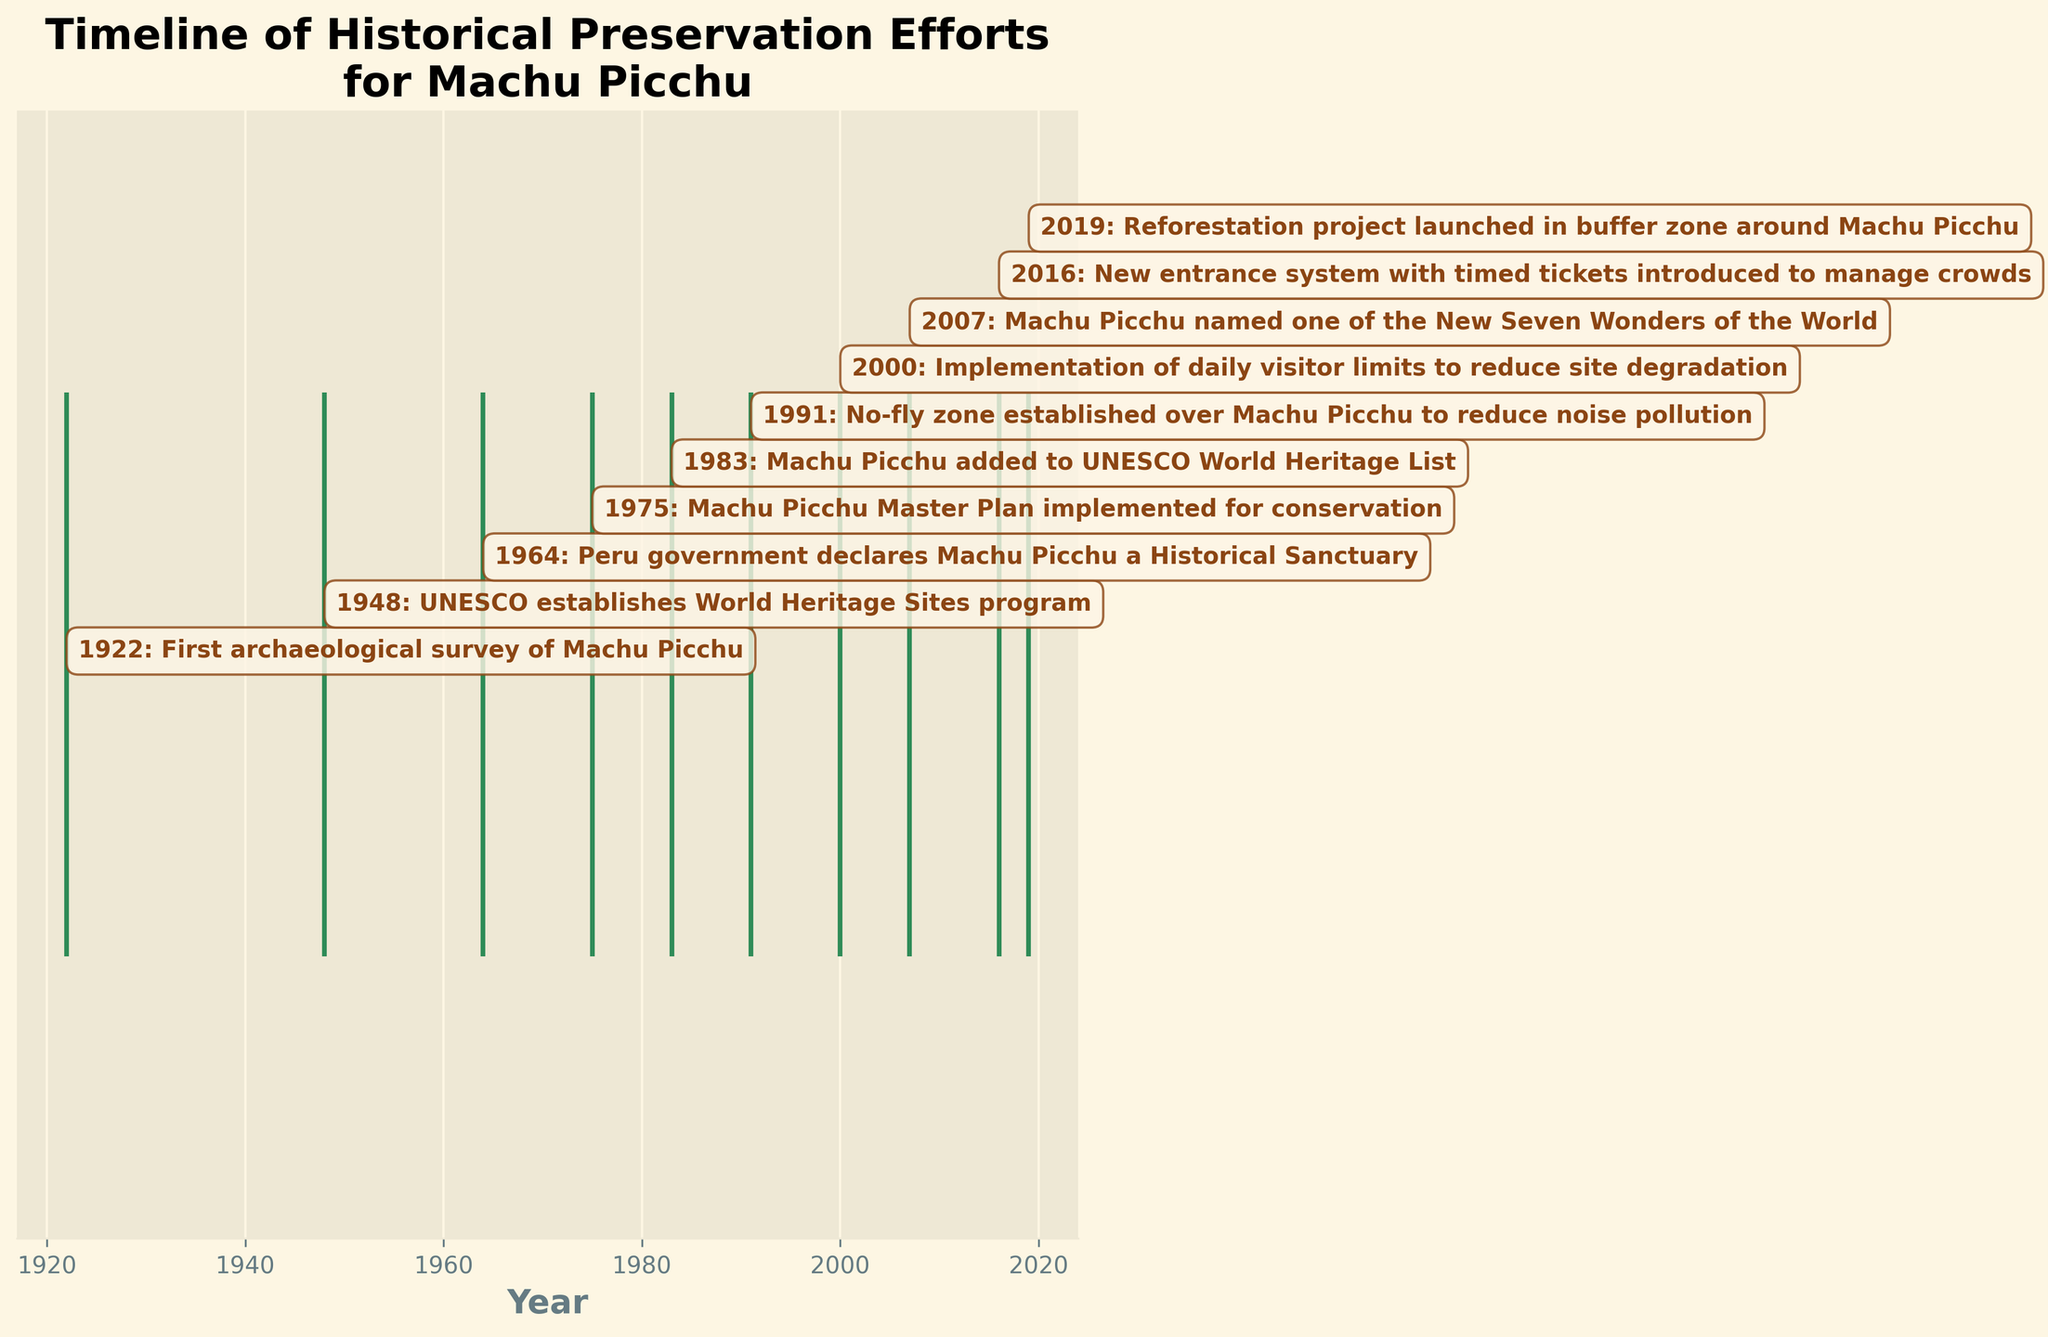what is the title of the plot? The title of the plot is displayed at the top center of the figure. It summarizes the theme of the plot.
Answer: Timeline of Historical Preservation Efforts for Machu Picchu What is the first recorded event in the timeline? The first recorded event appears at the beginning of the horizontal timeline on the left side of the plot, with an annotation box indicating the year and event.
Answer: 1922: First archaeological survey of Machu Picchu How many historical preservation events are recorded in the timeline? Each vertical line in the event plot represents one historical preservation event. By counting these lines, we can determine the total number of events.
Answer: 10 What event occurred in 1983? Looking at the horizontal axis, locate the annotation corresponding to the year 1983. The annotation will provide the event's details.
Answer: Machu Picchu added to UNESCO World Heritage List Which three events occurred closest to each other in time? Examine the horizontal placements of the event lines to find the years that are closest in proximity. Identify the years with minimal gaps between them and check the corresponding annotations.
Answer: 2000, 2007, 2016 How many years after the declaration of Machu Picchu as a Historical Sanctuary was it added to the UNESCO World Heritage List? Identify the years when each event occurred (1964 and 1983), then calculate the difference between these years. 1983 - 1964
Answer: 19 years Which event happened more recently: the introduction of a new entrance system or the reforestation project? Compare the years of the two events from their annotations and identify the more recent year.
Answer: Reforestation project launched in 2019 What changes were implemented to manage crowds at Machu Picchu in 2016? Locate the annotation for the year 2016 and read the description of the event.
Answer: New entrance system with timed tickets introduced How long after the establishment of the UNESCO World Heritage Sites program was Machu Picchu included in the list? Determine the years when the UNESCO program was established (1948) and when Machu Picchu was added to the list (1983). Compute the difference between these years. 1983 - 1948
Answer: 35 years Which event was implemented to reduce site degradation, and in what year did it happen? Find the annotation that describes reducing site degradation and note the year associated with it.
Answer: Implementation of daily visitor limits to reduce site degradation in 2000 